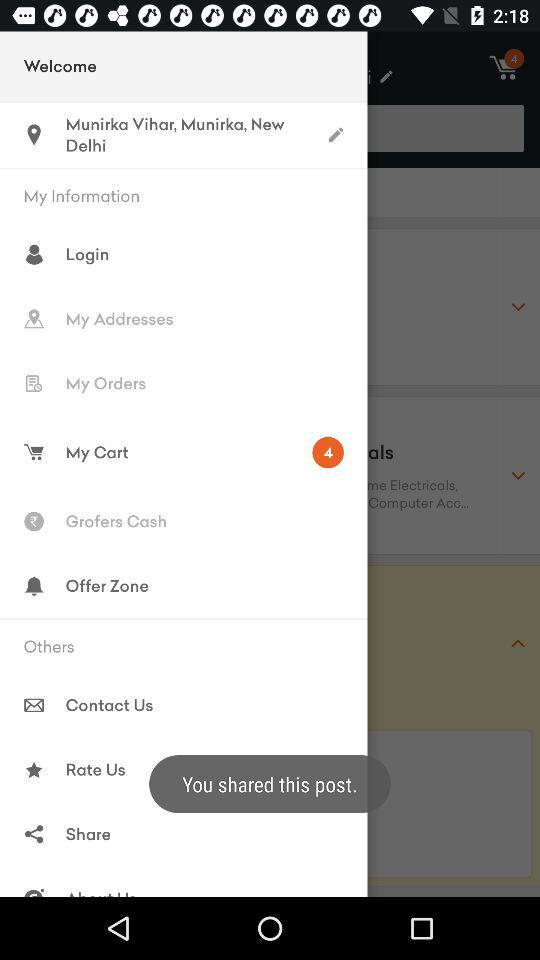How many items are in the cart?
Answer the question using a single word or phrase. 4 